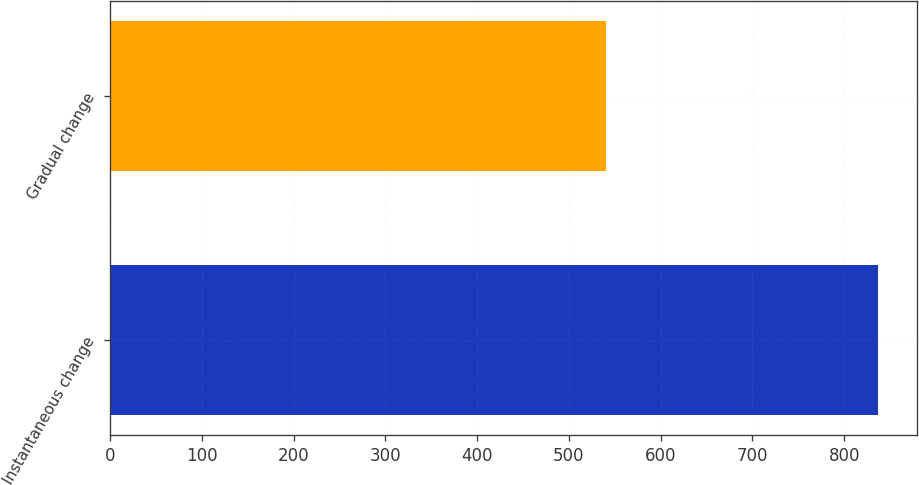Convert chart. <chart><loc_0><loc_0><loc_500><loc_500><bar_chart><fcel>Instantaneous change<fcel>Gradual change<nl><fcel>837<fcel>540<nl></chart> 